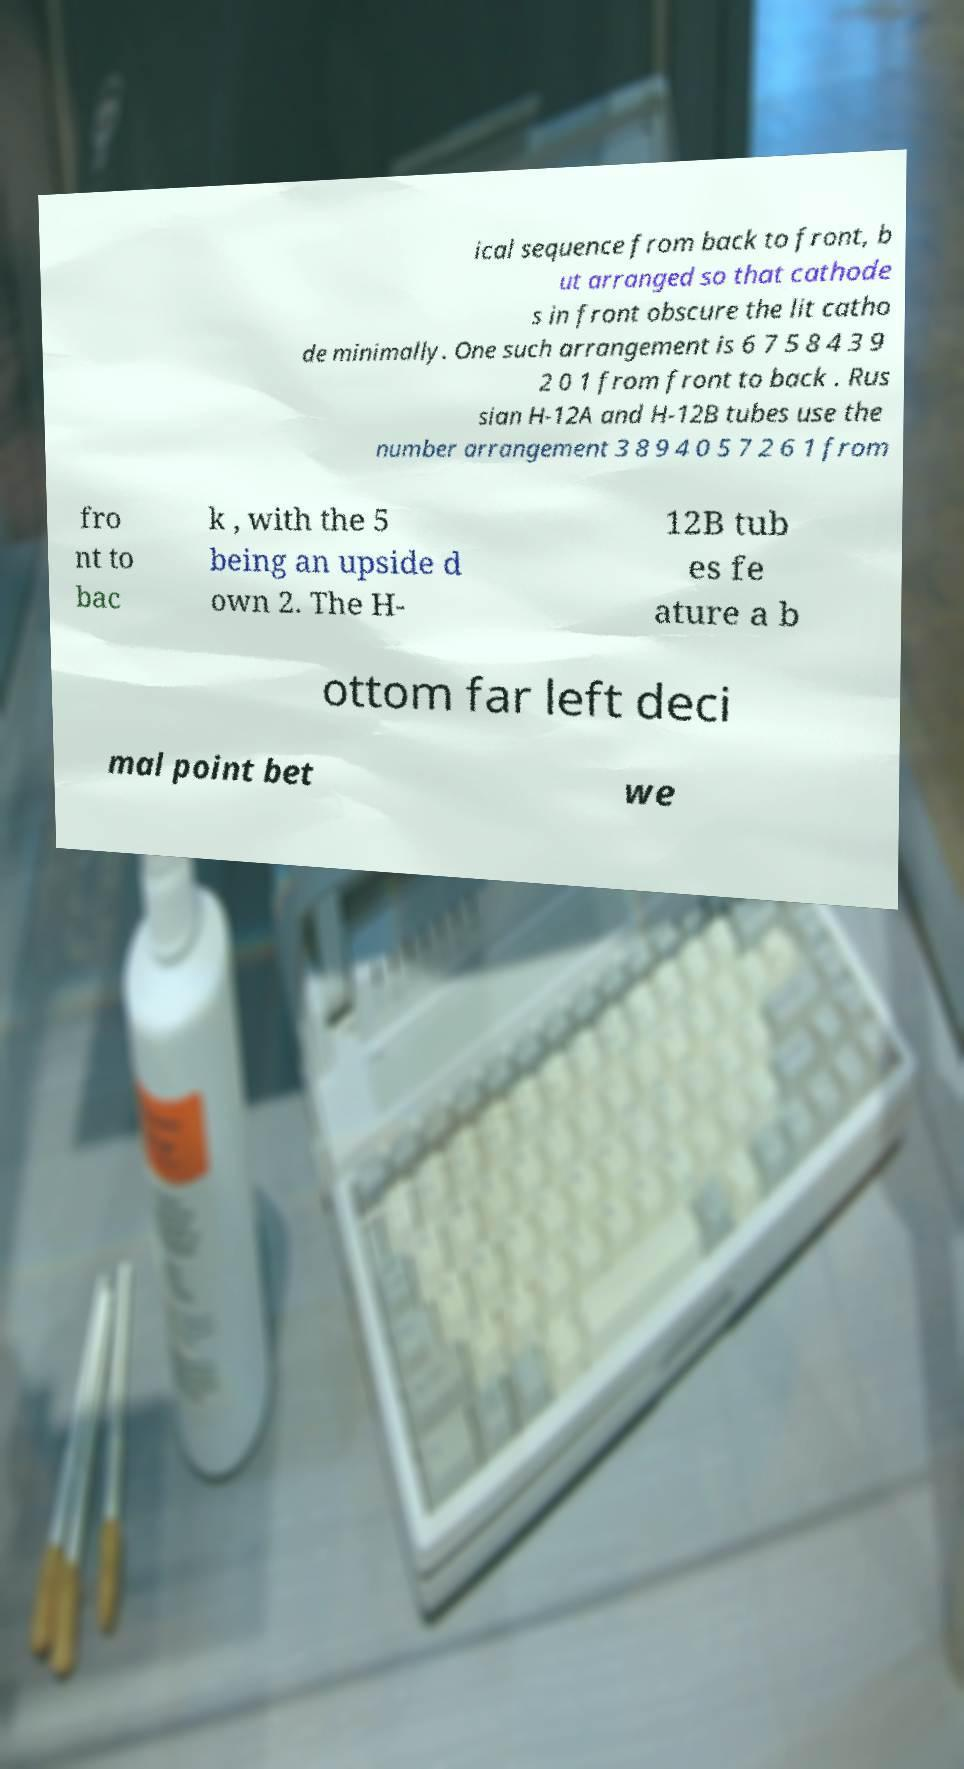Can you read and provide the text displayed in the image?This photo seems to have some interesting text. Can you extract and type it out for me? ical sequence from back to front, b ut arranged so that cathode s in front obscure the lit catho de minimally. One such arrangement is 6 7 5 8 4 3 9 2 0 1 from front to back . Rus sian H-12A and H-12B tubes use the number arrangement 3 8 9 4 0 5 7 2 6 1 from fro nt to bac k , with the 5 being an upside d own 2. The H- 12B tub es fe ature a b ottom far left deci mal point bet we 